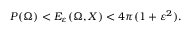Convert formula to latex. <formula><loc_0><loc_0><loc_500><loc_500>P ( \Omega ) < E _ { \varepsilon } ( \Omega , X ) < 4 \pi ( 1 + \varepsilon ^ { 2 } ) .</formula> 